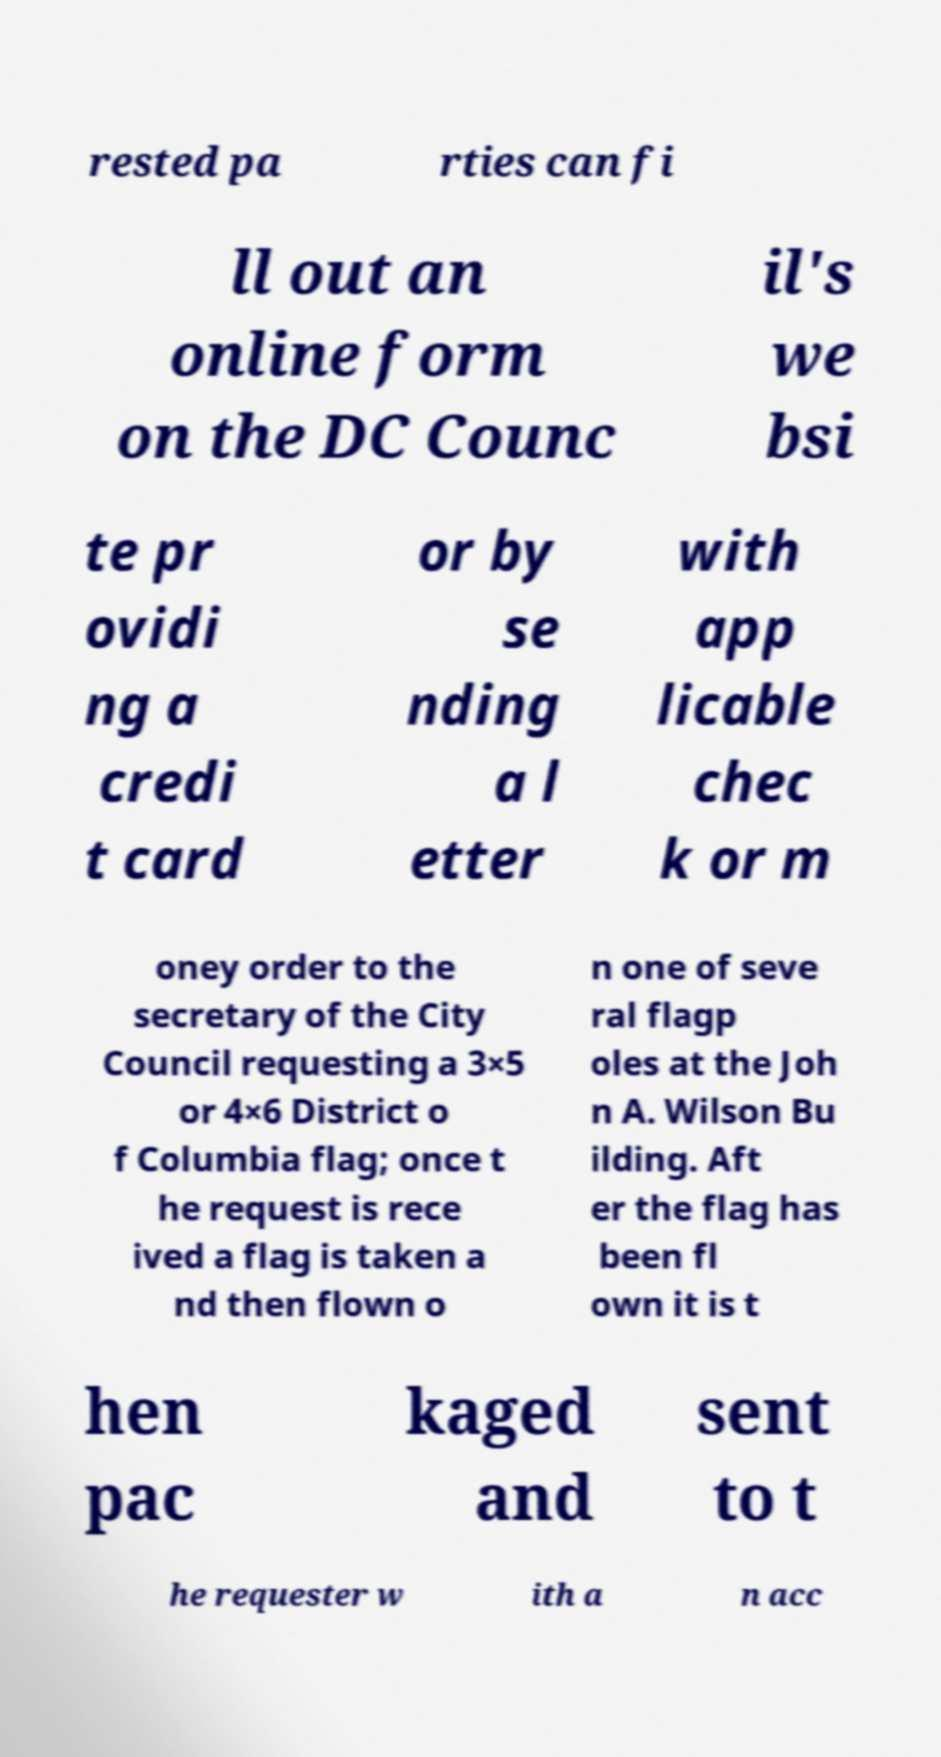For documentation purposes, I need the text within this image transcribed. Could you provide that? rested pa rties can fi ll out an online form on the DC Counc il's we bsi te pr ovidi ng a credi t card or by se nding a l etter with app licable chec k or m oney order to the secretary of the City Council requesting a 3×5 or 4×6 District o f Columbia flag; once t he request is rece ived a flag is taken a nd then flown o n one of seve ral flagp oles at the Joh n A. Wilson Bu ilding. Aft er the flag has been fl own it is t hen pac kaged and sent to t he requester w ith a n acc 